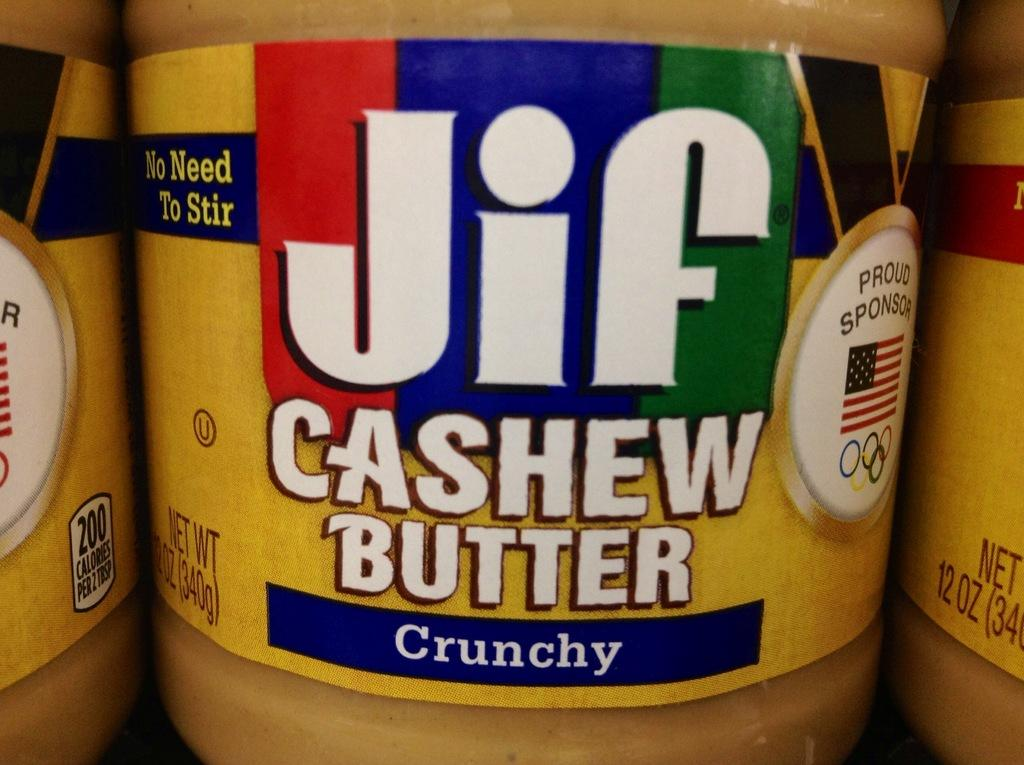<image>
Render a clear and concise summary of the photo. A close up of a colourful Jif cashew butter jar label. 